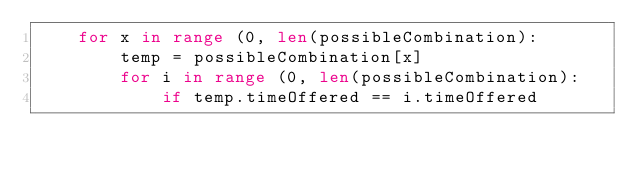<code> <loc_0><loc_0><loc_500><loc_500><_Python_>	for x in range (0, len(possibleCombination):
		temp = possibleCombination[x]
		for i in range (0, len(possibleCombination):
			if temp.timeOffered == i.timeOffered






</code> 